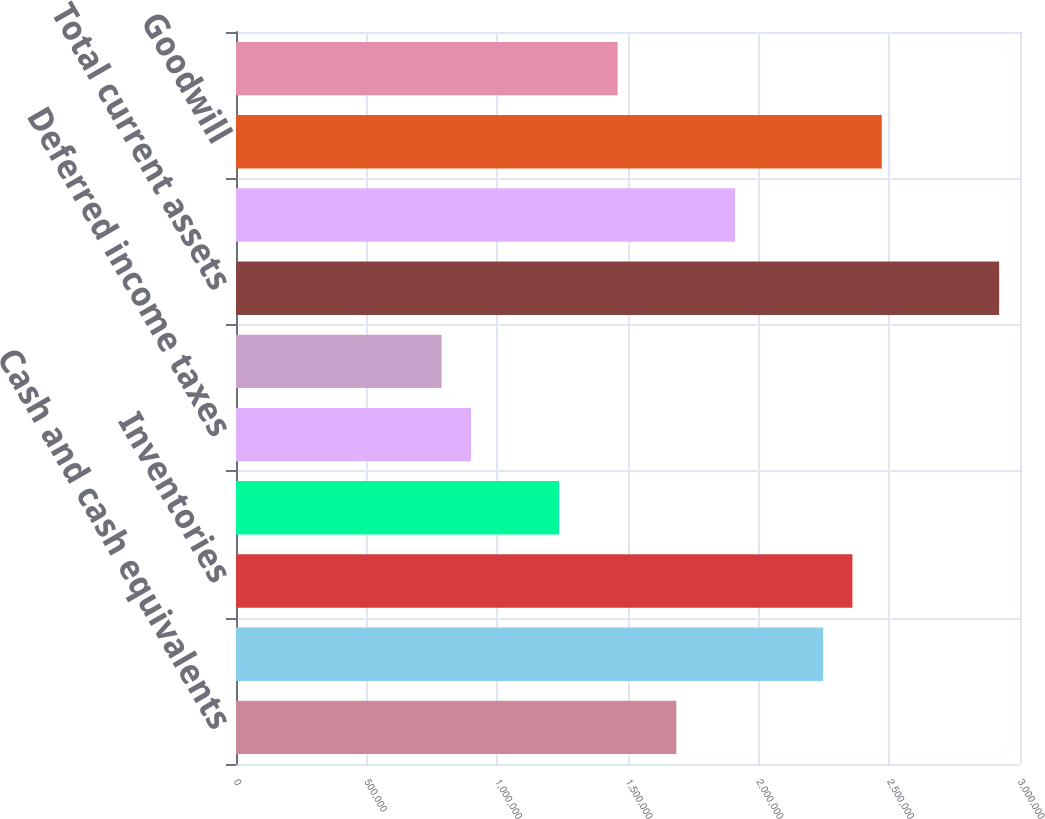Convert chart. <chart><loc_0><loc_0><loc_500><loc_500><bar_chart><fcel>Cash and cash equivalents<fcel>Receivables net<fcel>Inventories<fcel>Costs in excess of billings<fcel>Deferred income taxes<fcel>Prepaid and other current<fcel>Total current assets<fcel>Property plant and equipment<fcel>Goodwill<fcel>Intangibles net<nl><fcel>1.68505e+06<fcel>2.24646e+06<fcel>2.35874e+06<fcel>1.23592e+06<fcel>899069<fcel>786787<fcel>2.92015e+06<fcel>1.90961e+06<fcel>2.47102e+06<fcel>1.46048e+06<nl></chart> 